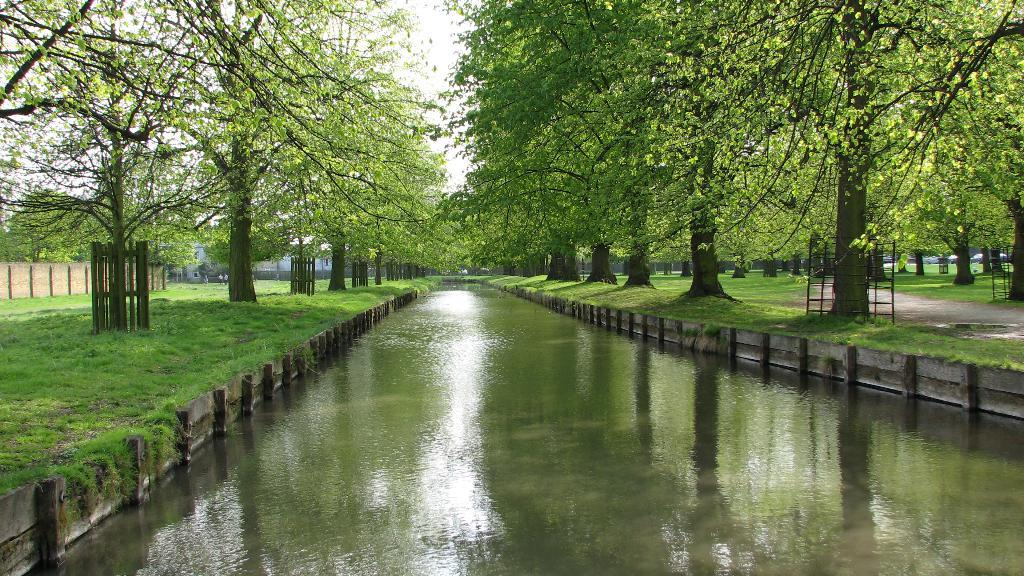What type of vegetation can be seen in the image? There are trees in the image. What is visible on the ground in the image? There is water and grass visible on the ground in the image. What is the condition of the sky in the image? The sky is cloudy in the image. What type of structure is present in the image? There is a wall in the image. What are the people in the image doing? The people are standing in the image. What type of enclosure is present around some trees in the image? There is a fence around some trees in the image. What type of leather is visible on the trees in the image? There is no leather present on the trees in the image. What are the people talking about in the image? The image does not provide any information about what the people might be talking about. 